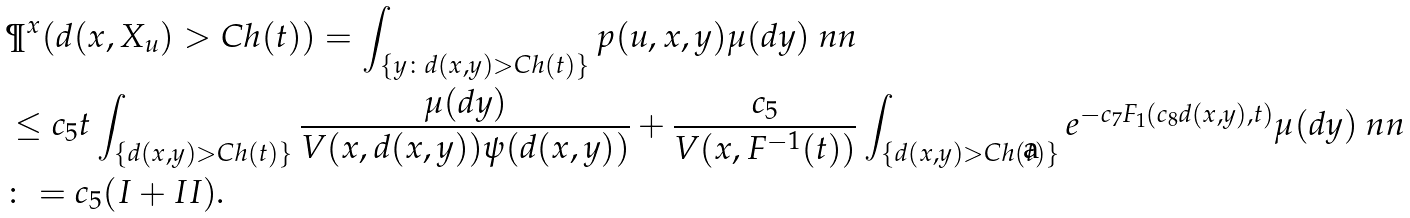<formula> <loc_0><loc_0><loc_500><loc_500>& \P ^ { x } ( d ( x , X _ { u } ) > C h ( t ) ) = \int _ { \{ y \colon d ( x , y ) > C h ( t ) \} } p ( u , x , y ) \mu ( d y ) \ n n \\ & \leq c _ { 5 } t \int _ { \{ d ( x , y ) > C h ( t ) \} } \frac { \mu ( d y ) } { V ( x , d ( x , y ) ) \psi ( d ( x , y ) ) } + \frac { c _ { 5 } } { V ( x , F ^ { - 1 } ( t ) ) } \int _ { \{ d ( x , y ) > C h ( t ) \} } e ^ { - c _ { 7 } F _ { 1 } ( c _ { 8 } d ( x , y ) , t ) } \mu ( d y ) \ n n \\ & \colon = c _ { 5 } ( I + I I ) .</formula> 